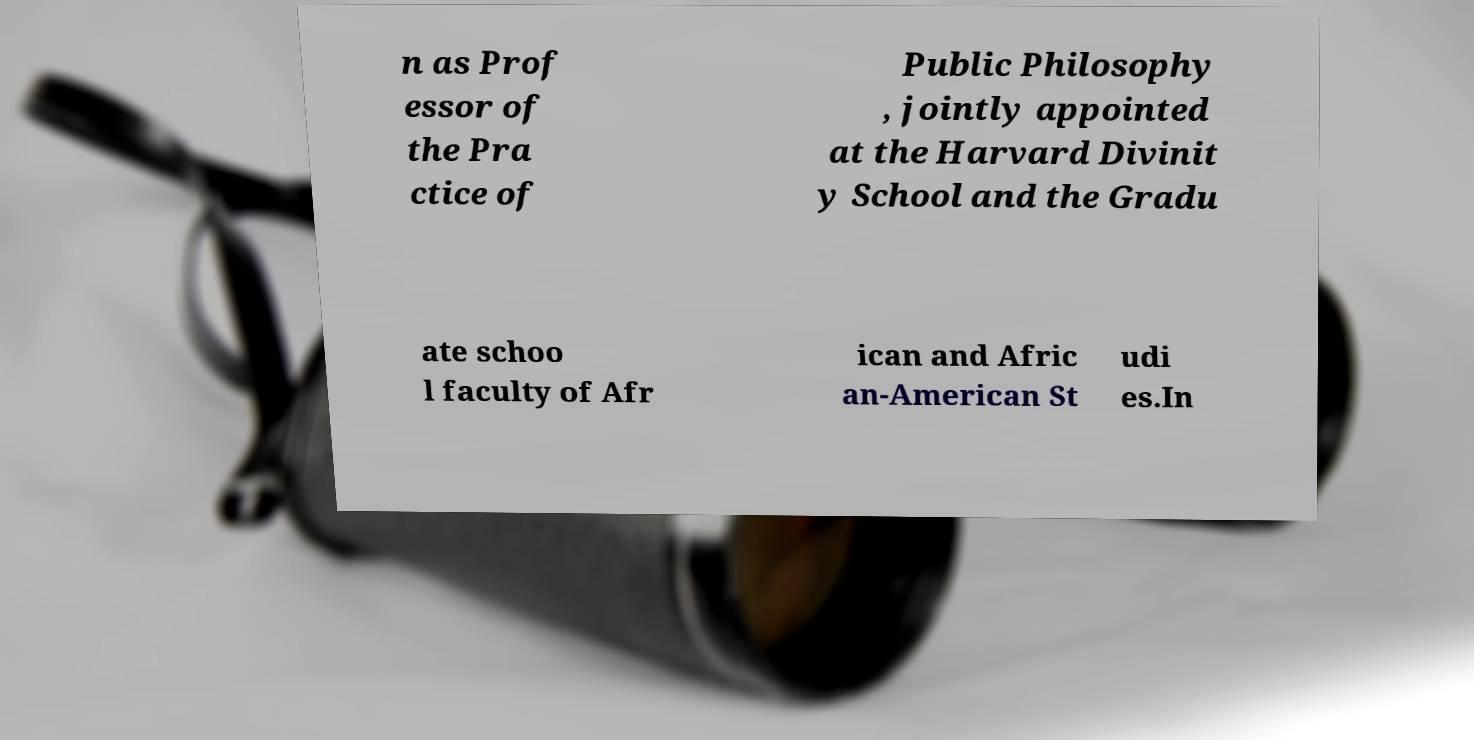Could you assist in decoding the text presented in this image and type it out clearly? n as Prof essor of the Pra ctice of Public Philosophy , jointly appointed at the Harvard Divinit y School and the Gradu ate schoo l faculty of Afr ican and Afric an-American St udi es.In 